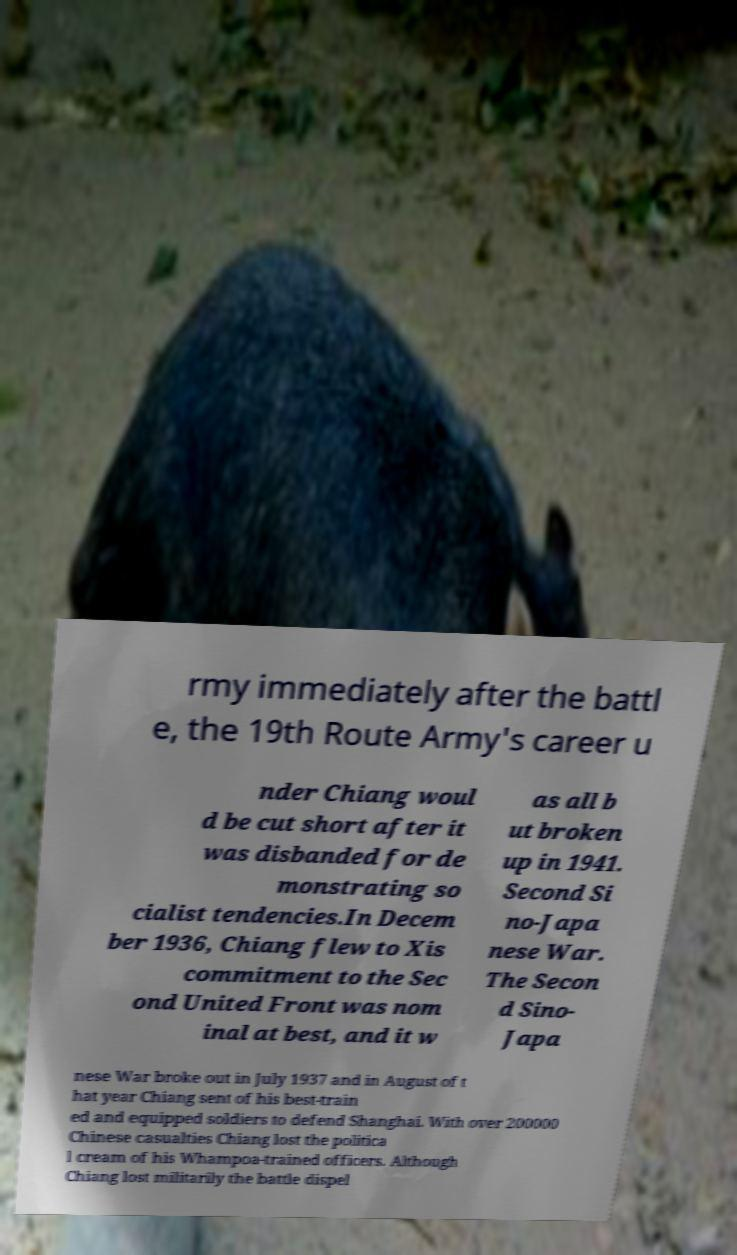For documentation purposes, I need the text within this image transcribed. Could you provide that? rmy immediately after the battl e, the 19th Route Army's career u nder Chiang woul d be cut short after it was disbanded for de monstrating so cialist tendencies.In Decem ber 1936, Chiang flew to Xis commitment to the Sec ond United Front was nom inal at best, and it w as all b ut broken up in 1941. Second Si no-Japa nese War. The Secon d Sino- Japa nese War broke out in July 1937 and in August of t hat year Chiang sent of his best-train ed and equipped soldiers to defend Shanghai. With over 200000 Chinese casualties Chiang lost the politica l cream of his Whampoa-trained officers. Although Chiang lost militarily the battle dispel 